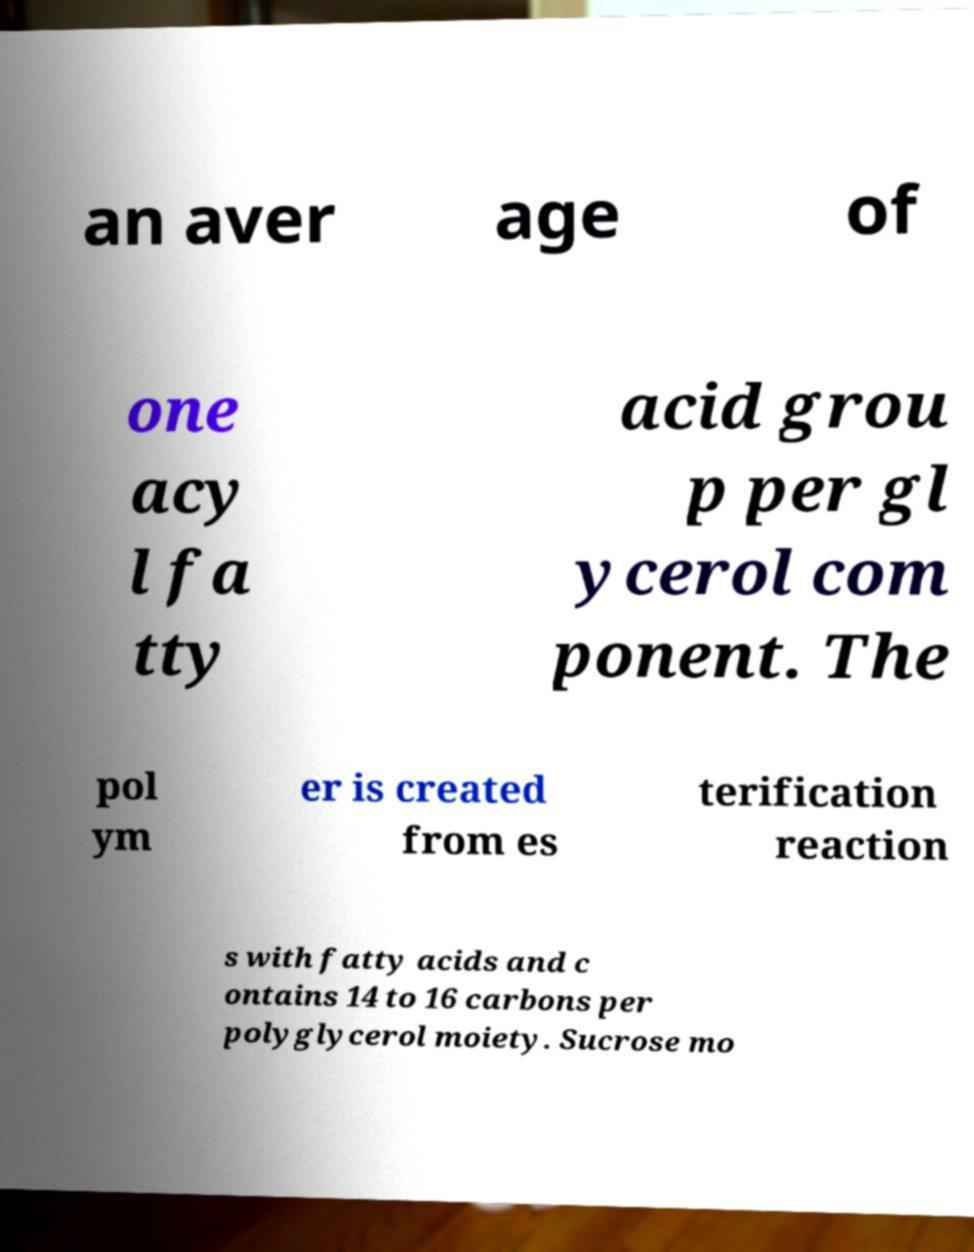What messages or text are displayed in this image? I need them in a readable, typed format. an aver age of one acy l fa tty acid grou p per gl ycerol com ponent. The pol ym er is created from es terification reaction s with fatty acids and c ontains 14 to 16 carbons per polyglycerol moiety. Sucrose mo 